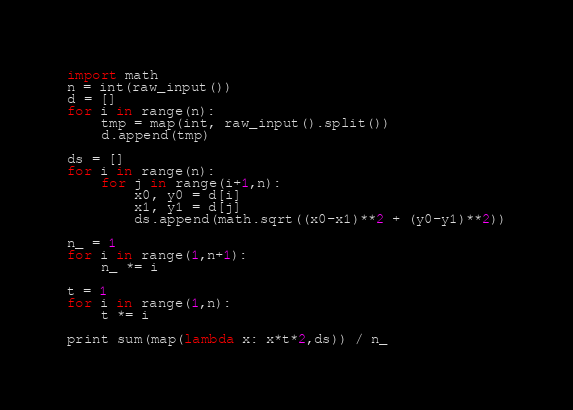Convert code to text. <code><loc_0><loc_0><loc_500><loc_500><_Python_>import math
n = int(raw_input())
d = []
for i in range(n):
    tmp = map(int, raw_input().split())
    d.append(tmp)

ds = []
for i in range(n):
    for j in range(i+1,n):
        x0, y0 = d[i]
        x1, y1 = d[j]
        ds.append(math.sqrt((x0-x1)**2 + (y0-y1)**2))

n_ = 1
for i in range(1,n+1):
    n_ *= i

t = 1
for i in range(1,n):
    t *= i

print sum(map(lambda x: x*t*2,ds)) / n_
</code> 